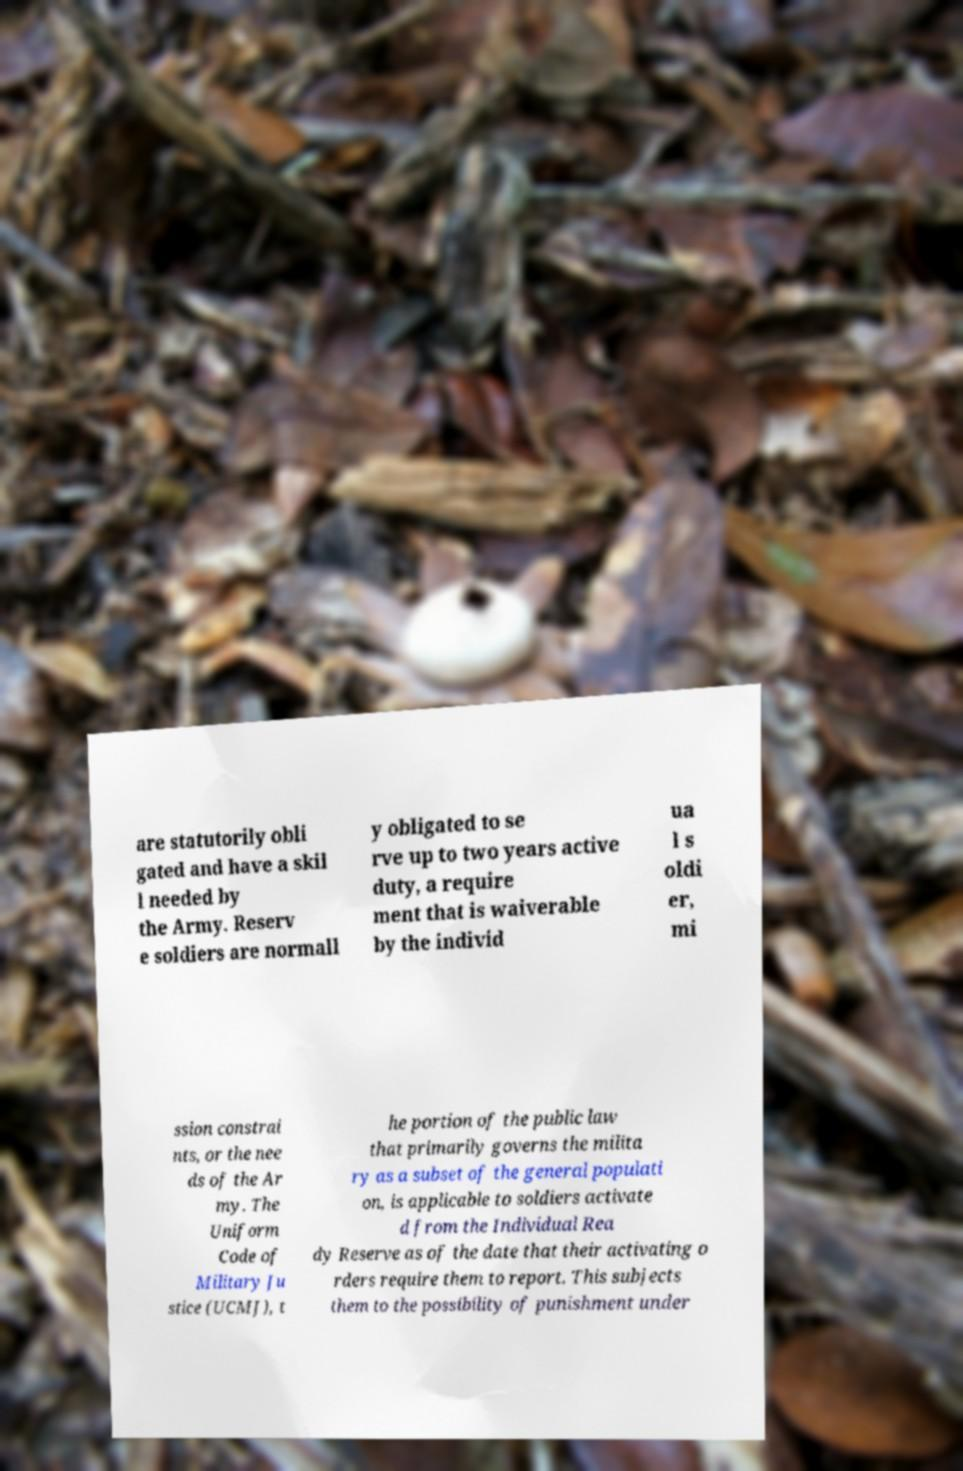Can you accurately transcribe the text from the provided image for me? are statutorily obli gated and have a skil l needed by the Army. Reserv e soldiers are normall y obligated to se rve up to two years active duty, a require ment that is waiverable by the individ ua l s oldi er, mi ssion constrai nts, or the nee ds of the Ar my. The Uniform Code of Military Ju stice (UCMJ), t he portion of the public law that primarily governs the milita ry as a subset of the general populati on, is applicable to soldiers activate d from the Individual Rea dy Reserve as of the date that their activating o rders require them to report. This subjects them to the possibility of punishment under 